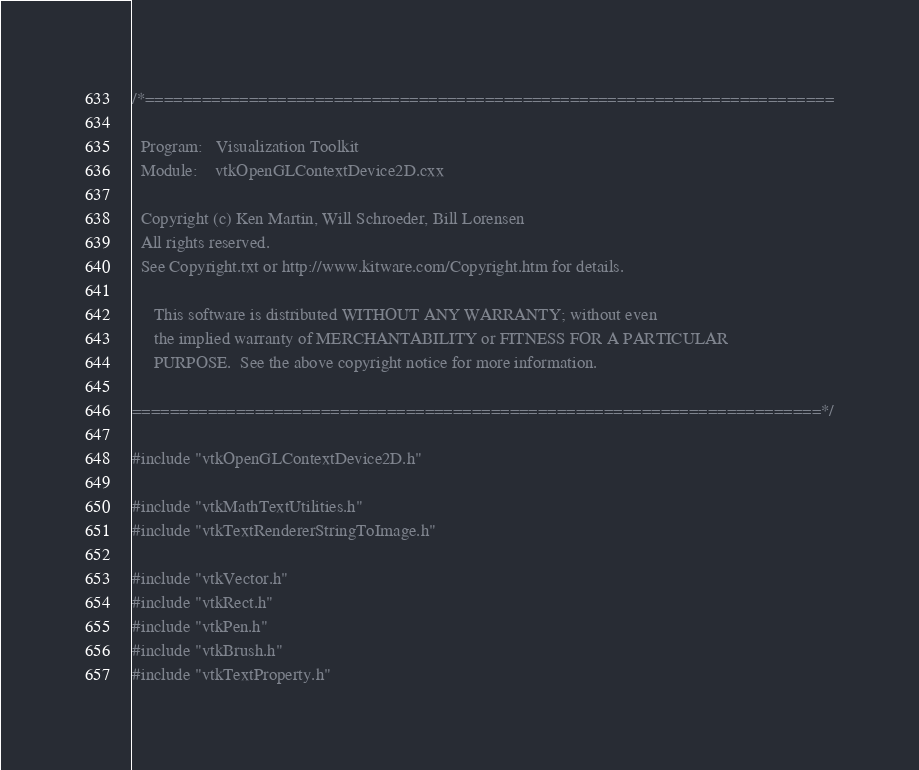Convert code to text. <code><loc_0><loc_0><loc_500><loc_500><_C++_>/*=========================================================================

  Program:   Visualization Toolkit
  Module:    vtkOpenGLContextDevice2D.cxx

  Copyright (c) Ken Martin, Will Schroeder, Bill Lorensen
  All rights reserved.
  See Copyright.txt or http://www.kitware.com/Copyright.htm for details.

     This software is distributed WITHOUT ANY WARRANTY; without even
     the implied warranty of MERCHANTABILITY or FITNESS FOR A PARTICULAR
     PURPOSE.  See the above copyright notice for more information.

=========================================================================*/

#include "vtkOpenGLContextDevice2D.h"

#include "vtkMathTextUtilities.h"
#include "vtkTextRendererStringToImage.h"

#include "vtkVector.h"
#include "vtkRect.h"
#include "vtkPen.h"
#include "vtkBrush.h"
#include "vtkTextProperty.h"</code> 